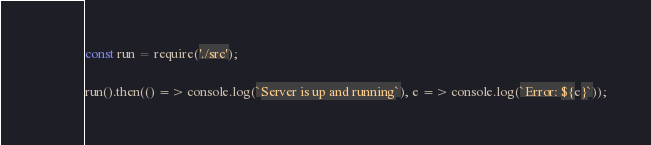Convert code to text. <code><loc_0><loc_0><loc_500><loc_500><_JavaScript_>const run = require('./src');

run().then(() => console.log(`Server is up and running`), e => console.log(`Error: ${e}`));
</code> 